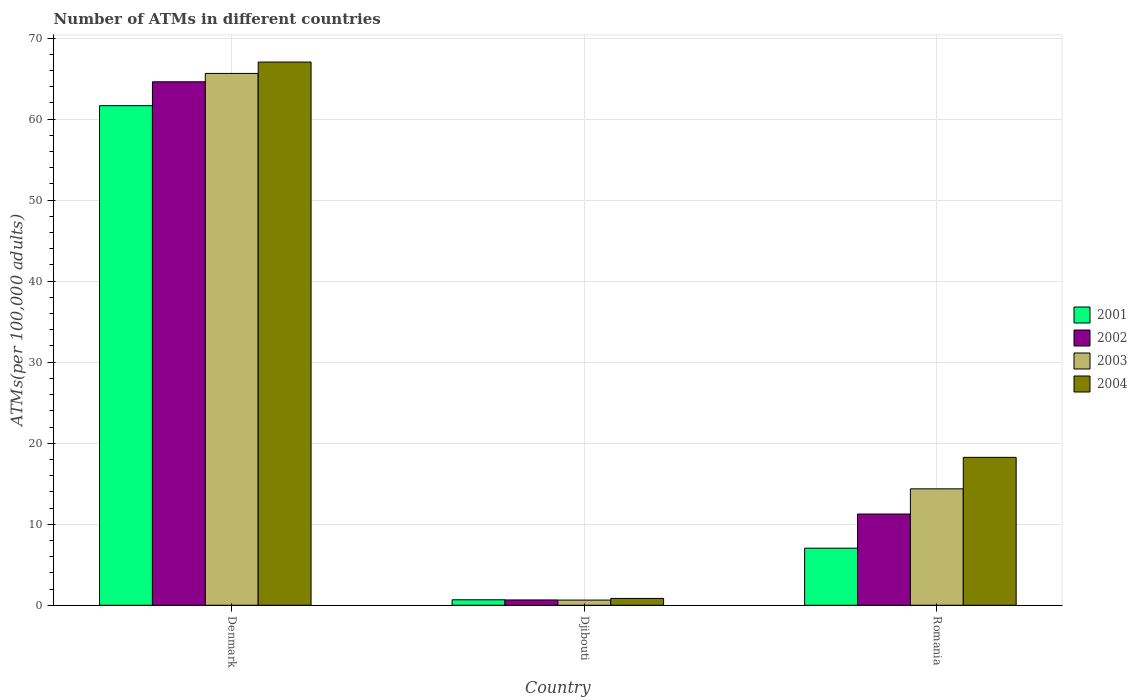How many different coloured bars are there?
Give a very brief answer. 4. Are the number of bars on each tick of the X-axis equal?
Offer a terse response. Yes. How many bars are there on the 2nd tick from the left?
Keep it short and to the point. 4. How many bars are there on the 3rd tick from the right?
Offer a very short reply. 4. In how many cases, is the number of bars for a given country not equal to the number of legend labels?
Offer a very short reply. 0. What is the number of ATMs in 2002 in Romania?
Provide a succinct answer. 11.26. Across all countries, what is the maximum number of ATMs in 2003?
Your answer should be very brief. 65.64. Across all countries, what is the minimum number of ATMs in 2001?
Make the answer very short. 0.68. In which country was the number of ATMs in 2001 minimum?
Your answer should be compact. Djibouti. What is the total number of ATMs in 2003 in the graph?
Your response must be concise. 80.65. What is the difference between the number of ATMs in 2003 in Djibouti and that in Romania?
Your answer should be compact. -13.73. What is the difference between the number of ATMs in 2003 in Romania and the number of ATMs in 2002 in Denmark?
Ensure brevity in your answer.  -50.24. What is the average number of ATMs in 2002 per country?
Ensure brevity in your answer.  25.51. What is the difference between the number of ATMs of/in 2003 and number of ATMs of/in 2002 in Romania?
Provide a short and direct response. 3.11. What is the ratio of the number of ATMs in 2002 in Denmark to that in Djibouti?
Offer a terse response. 98.45. Is the number of ATMs in 2002 in Denmark less than that in Djibouti?
Provide a succinct answer. No. What is the difference between the highest and the second highest number of ATMs in 2003?
Give a very brief answer. -65. What is the difference between the highest and the lowest number of ATMs in 2002?
Keep it short and to the point. 63.95. In how many countries, is the number of ATMs in 2003 greater than the average number of ATMs in 2003 taken over all countries?
Your answer should be compact. 1. Is the sum of the number of ATMs in 2004 in Djibouti and Romania greater than the maximum number of ATMs in 2002 across all countries?
Your response must be concise. No. What does the 4th bar from the left in Romania represents?
Your answer should be compact. 2004. How many bars are there?
Offer a very short reply. 12. Are all the bars in the graph horizontal?
Your response must be concise. No. How many countries are there in the graph?
Make the answer very short. 3. What is the difference between two consecutive major ticks on the Y-axis?
Provide a short and direct response. 10. Does the graph contain grids?
Your answer should be compact. Yes. Where does the legend appear in the graph?
Offer a terse response. Center right. How are the legend labels stacked?
Ensure brevity in your answer.  Vertical. What is the title of the graph?
Provide a succinct answer. Number of ATMs in different countries. What is the label or title of the X-axis?
Offer a terse response. Country. What is the label or title of the Y-axis?
Give a very brief answer. ATMs(per 100,0 adults). What is the ATMs(per 100,000 adults) in 2001 in Denmark?
Provide a short and direct response. 61.66. What is the ATMs(per 100,000 adults) of 2002 in Denmark?
Offer a very short reply. 64.61. What is the ATMs(per 100,000 adults) in 2003 in Denmark?
Your response must be concise. 65.64. What is the ATMs(per 100,000 adults) in 2004 in Denmark?
Keep it short and to the point. 67.04. What is the ATMs(per 100,000 adults) of 2001 in Djibouti?
Provide a succinct answer. 0.68. What is the ATMs(per 100,000 adults) in 2002 in Djibouti?
Your answer should be compact. 0.66. What is the ATMs(per 100,000 adults) in 2003 in Djibouti?
Provide a succinct answer. 0.64. What is the ATMs(per 100,000 adults) of 2004 in Djibouti?
Your answer should be compact. 0.84. What is the ATMs(per 100,000 adults) in 2001 in Romania?
Give a very brief answer. 7.04. What is the ATMs(per 100,000 adults) of 2002 in Romania?
Give a very brief answer. 11.26. What is the ATMs(per 100,000 adults) in 2003 in Romania?
Your answer should be compact. 14.37. What is the ATMs(per 100,000 adults) of 2004 in Romania?
Your answer should be very brief. 18.26. Across all countries, what is the maximum ATMs(per 100,000 adults) of 2001?
Offer a terse response. 61.66. Across all countries, what is the maximum ATMs(per 100,000 adults) in 2002?
Keep it short and to the point. 64.61. Across all countries, what is the maximum ATMs(per 100,000 adults) of 2003?
Ensure brevity in your answer.  65.64. Across all countries, what is the maximum ATMs(per 100,000 adults) of 2004?
Give a very brief answer. 67.04. Across all countries, what is the minimum ATMs(per 100,000 adults) in 2001?
Ensure brevity in your answer.  0.68. Across all countries, what is the minimum ATMs(per 100,000 adults) of 2002?
Give a very brief answer. 0.66. Across all countries, what is the minimum ATMs(per 100,000 adults) in 2003?
Give a very brief answer. 0.64. Across all countries, what is the minimum ATMs(per 100,000 adults) of 2004?
Give a very brief answer. 0.84. What is the total ATMs(per 100,000 adults) in 2001 in the graph?
Ensure brevity in your answer.  69.38. What is the total ATMs(per 100,000 adults) in 2002 in the graph?
Offer a terse response. 76.52. What is the total ATMs(per 100,000 adults) of 2003 in the graph?
Your answer should be compact. 80.65. What is the total ATMs(per 100,000 adults) of 2004 in the graph?
Make the answer very short. 86.14. What is the difference between the ATMs(per 100,000 adults) in 2001 in Denmark and that in Djibouti?
Give a very brief answer. 60.98. What is the difference between the ATMs(per 100,000 adults) in 2002 in Denmark and that in Djibouti?
Provide a succinct answer. 63.95. What is the difference between the ATMs(per 100,000 adults) in 2003 in Denmark and that in Djibouti?
Keep it short and to the point. 65. What is the difference between the ATMs(per 100,000 adults) of 2004 in Denmark and that in Djibouti?
Your response must be concise. 66.2. What is the difference between the ATMs(per 100,000 adults) in 2001 in Denmark and that in Romania?
Offer a terse response. 54.61. What is the difference between the ATMs(per 100,000 adults) in 2002 in Denmark and that in Romania?
Keep it short and to the point. 53.35. What is the difference between the ATMs(per 100,000 adults) of 2003 in Denmark and that in Romania?
Your answer should be compact. 51.27. What is the difference between the ATMs(per 100,000 adults) in 2004 in Denmark and that in Romania?
Keep it short and to the point. 48.79. What is the difference between the ATMs(per 100,000 adults) in 2001 in Djibouti and that in Romania?
Your answer should be compact. -6.37. What is the difference between the ATMs(per 100,000 adults) in 2002 in Djibouti and that in Romania?
Offer a terse response. -10.6. What is the difference between the ATMs(per 100,000 adults) in 2003 in Djibouti and that in Romania?
Keep it short and to the point. -13.73. What is the difference between the ATMs(per 100,000 adults) of 2004 in Djibouti and that in Romania?
Provide a short and direct response. -17.41. What is the difference between the ATMs(per 100,000 adults) of 2001 in Denmark and the ATMs(per 100,000 adults) of 2002 in Djibouti?
Your response must be concise. 61. What is the difference between the ATMs(per 100,000 adults) of 2001 in Denmark and the ATMs(per 100,000 adults) of 2003 in Djibouti?
Your answer should be very brief. 61.02. What is the difference between the ATMs(per 100,000 adults) in 2001 in Denmark and the ATMs(per 100,000 adults) in 2004 in Djibouti?
Make the answer very short. 60.81. What is the difference between the ATMs(per 100,000 adults) in 2002 in Denmark and the ATMs(per 100,000 adults) in 2003 in Djibouti?
Ensure brevity in your answer.  63.97. What is the difference between the ATMs(per 100,000 adults) of 2002 in Denmark and the ATMs(per 100,000 adults) of 2004 in Djibouti?
Your response must be concise. 63.76. What is the difference between the ATMs(per 100,000 adults) of 2003 in Denmark and the ATMs(per 100,000 adults) of 2004 in Djibouti?
Make the answer very short. 64.79. What is the difference between the ATMs(per 100,000 adults) in 2001 in Denmark and the ATMs(per 100,000 adults) in 2002 in Romania?
Ensure brevity in your answer.  50.4. What is the difference between the ATMs(per 100,000 adults) in 2001 in Denmark and the ATMs(per 100,000 adults) in 2003 in Romania?
Give a very brief answer. 47.29. What is the difference between the ATMs(per 100,000 adults) of 2001 in Denmark and the ATMs(per 100,000 adults) of 2004 in Romania?
Offer a terse response. 43.4. What is the difference between the ATMs(per 100,000 adults) of 2002 in Denmark and the ATMs(per 100,000 adults) of 2003 in Romania?
Give a very brief answer. 50.24. What is the difference between the ATMs(per 100,000 adults) in 2002 in Denmark and the ATMs(per 100,000 adults) in 2004 in Romania?
Make the answer very short. 46.35. What is the difference between the ATMs(per 100,000 adults) of 2003 in Denmark and the ATMs(per 100,000 adults) of 2004 in Romania?
Your answer should be compact. 47.38. What is the difference between the ATMs(per 100,000 adults) in 2001 in Djibouti and the ATMs(per 100,000 adults) in 2002 in Romania?
Offer a terse response. -10.58. What is the difference between the ATMs(per 100,000 adults) of 2001 in Djibouti and the ATMs(per 100,000 adults) of 2003 in Romania?
Offer a terse response. -13.69. What is the difference between the ATMs(per 100,000 adults) of 2001 in Djibouti and the ATMs(per 100,000 adults) of 2004 in Romania?
Your response must be concise. -17.58. What is the difference between the ATMs(per 100,000 adults) in 2002 in Djibouti and the ATMs(per 100,000 adults) in 2003 in Romania?
Ensure brevity in your answer.  -13.71. What is the difference between the ATMs(per 100,000 adults) in 2002 in Djibouti and the ATMs(per 100,000 adults) in 2004 in Romania?
Give a very brief answer. -17.6. What is the difference between the ATMs(per 100,000 adults) of 2003 in Djibouti and the ATMs(per 100,000 adults) of 2004 in Romania?
Make the answer very short. -17.62. What is the average ATMs(per 100,000 adults) in 2001 per country?
Make the answer very short. 23.13. What is the average ATMs(per 100,000 adults) of 2002 per country?
Make the answer very short. 25.51. What is the average ATMs(per 100,000 adults) in 2003 per country?
Offer a terse response. 26.88. What is the average ATMs(per 100,000 adults) in 2004 per country?
Offer a very short reply. 28.71. What is the difference between the ATMs(per 100,000 adults) in 2001 and ATMs(per 100,000 adults) in 2002 in Denmark?
Keep it short and to the point. -2.95. What is the difference between the ATMs(per 100,000 adults) of 2001 and ATMs(per 100,000 adults) of 2003 in Denmark?
Provide a succinct answer. -3.98. What is the difference between the ATMs(per 100,000 adults) in 2001 and ATMs(per 100,000 adults) in 2004 in Denmark?
Your answer should be compact. -5.39. What is the difference between the ATMs(per 100,000 adults) in 2002 and ATMs(per 100,000 adults) in 2003 in Denmark?
Give a very brief answer. -1.03. What is the difference between the ATMs(per 100,000 adults) of 2002 and ATMs(per 100,000 adults) of 2004 in Denmark?
Give a very brief answer. -2.44. What is the difference between the ATMs(per 100,000 adults) in 2003 and ATMs(per 100,000 adults) in 2004 in Denmark?
Ensure brevity in your answer.  -1.41. What is the difference between the ATMs(per 100,000 adults) of 2001 and ATMs(per 100,000 adults) of 2002 in Djibouti?
Your answer should be compact. 0.02. What is the difference between the ATMs(per 100,000 adults) of 2001 and ATMs(per 100,000 adults) of 2003 in Djibouti?
Provide a succinct answer. 0.04. What is the difference between the ATMs(per 100,000 adults) of 2001 and ATMs(per 100,000 adults) of 2004 in Djibouti?
Ensure brevity in your answer.  -0.17. What is the difference between the ATMs(per 100,000 adults) of 2002 and ATMs(per 100,000 adults) of 2003 in Djibouti?
Your answer should be very brief. 0.02. What is the difference between the ATMs(per 100,000 adults) in 2002 and ATMs(per 100,000 adults) in 2004 in Djibouti?
Offer a very short reply. -0.19. What is the difference between the ATMs(per 100,000 adults) in 2003 and ATMs(per 100,000 adults) in 2004 in Djibouti?
Give a very brief answer. -0.21. What is the difference between the ATMs(per 100,000 adults) of 2001 and ATMs(per 100,000 adults) of 2002 in Romania?
Keep it short and to the point. -4.21. What is the difference between the ATMs(per 100,000 adults) in 2001 and ATMs(per 100,000 adults) in 2003 in Romania?
Your answer should be very brief. -7.32. What is the difference between the ATMs(per 100,000 adults) of 2001 and ATMs(per 100,000 adults) of 2004 in Romania?
Offer a very short reply. -11.21. What is the difference between the ATMs(per 100,000 adults) of 2002 and ATMs(per 100,000 adults) of 2003 in Romania?
Ensure brevity in your answer.  -3.11. What is the difference between the ATMs(per 100,000 adults) of 2002 and ATMs(per 100,000 adults) of 2004 in Romania?
Keep it short and to the point. -7. What is the difference between the ATMs(per 100,000 adults) in 2003 and ATMs(per 100,000 adults) in 2004 in Romania?
Offer a very short reply. -3.89. What is the ratio of the ATMs(per 100,000 adults) in 2001 in Denmark to that in Djibouti?
Ensure brevity in your answer.  91.18. What is the ratio of the ATMs(per 100,000 adults) of 2002 in Denmark to that in Djibouti?
Make the answer very short. 98.45. What is the ratio of the ATMs(per 100,000 adults) of 2003 in Denmark to that in Djibouti?
Provide a short and direct response. 102.88. What is the ratio of the ATMs(per 100,000 adults) of 2004 in Denmark to that in Djibouti?
Ensure brevity in your answer.  79.46. What is the ratio of the ATMs(per 100,000 adults) in 2001 in Denmark to that in Romania?
Make the answer very short. 8.75. What is the ratio of the ATMs(per 100,000 adults) in 2002 in Denmark to that in Romania?
Provide a succinct answer. 5.74. What is the ratio of the ATMs(per 100,000 adults) of 2003 in Denmark to that in Romania?
Your answer should be compact. 4.57. What is the ratio of the ATMs(per 100,000 adults) of 2004 in Denmark to that in Romania?
Offer a very short reply. 3.67. What is the ratio of the ATMs(per 100,000 adults) of 2001 in Djibouti to that in Romania?
Your answer should be very brief. 0.1. What is the ratio of the ATMs(per 100,000 adults) in 2002 in Djibouti to that in Romania?
Your answer should be compact. 0.06. What is the ratio of the ATMs(per 100,000 adults) in 2003 in Djibouti to that in Romania?
Offer a very short reply. 0.04. What is the ratio of the ATMs(per 100,000 adults) of 2004 in Djibouti to that in Romania?
Your answer should be compact. 0.05. What is the difference between the highest and the second highest ATMs(per 100,000 adults) of 2001?
Make the answer very short. 54.61. What is the difference between the highest and the second highest ATMs(per 100,000 adults) of 2002?
Ensure brevity in your answer.  53.35. What is the difference between the highest and the second highest ATMs(per 100,000 adults) of 2003?
Make the answer very short. 51.27. What is the difference between the highest and the second highest ATMs(per 100,000 adults) in 2004?
Your response must be concise. 48.79. What is the difference between the highest and the lowest ATMs(per 100,000 adults) in 2001?
Ensure brevity in your answer.  60.98. What is the difference between the highest and the lowest ATMs(per 100,000 adults) of 2002?
Give a very brief answer. 63.95. What is the difference between the highest and the lowest ATMs(per 100,000 adults) of 2003?
Make the answer very short. 65. What is the difference between the highest and the lowest ATMs(per 100,000 adults) in 2004?
Your response must be concise. 66.2. 